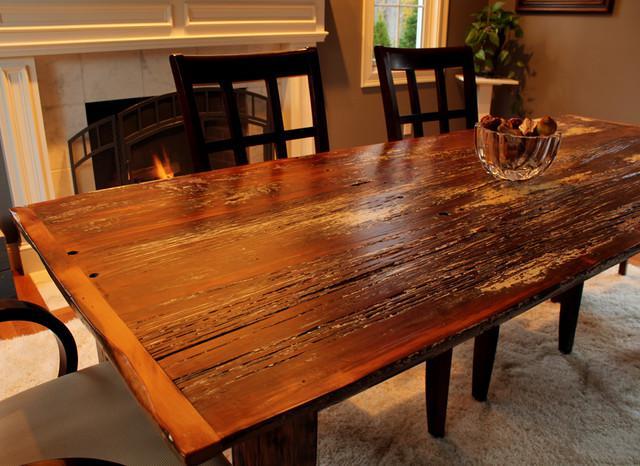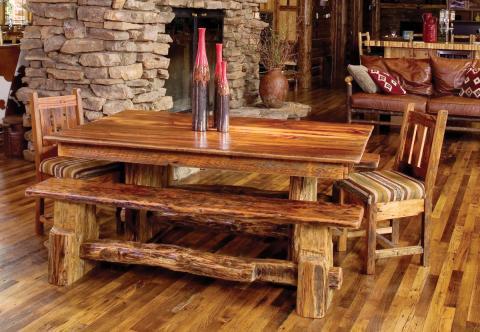The first image is the image on the left, the second image is the image on the right. Examine the images to the left and right. Is the description "In one image, a table has both chair and bench seating." accurate? Answer yes or no. Yes. The first image is the image on the left, the second image is the image on the right. Evaluate the accuracy of this statement regarding the images: "there are flowers on the table in the image on the right". Is it true? Answer yes or no. No. 